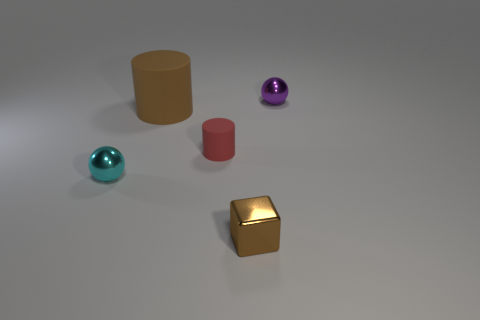How many metal things are either spheres or tiny cyan balls?
Make the answer very short. 2. Do the big brown cylinder and the cyan sphere have the same material?
Give a very brief answer. No. There is a ball that is behind the metallic sphere in front of the purple ball; what is it made of?
Give a very brief answer. Metal. How many tiny things are either metallic cubes or rubber cylinders?
Provide a short and direct response. 2. The purple shiny object has what size?
Your answer should be very brief. Small. Are there more balls that are in front of the brown rubber object than tiny cyan things?
Ensure brevity in your answer.  No. Are there an equal number of small cyan shiny balls in front of the cyan metal thing and large brown rubber cylinders in front of the small brown thing?
Offer a terse response. Yes. The small shiny thing that is both in front of the tiny purple metallic thing and behind the tiny brown metal block is what color?
Ensure brevity in your answer.  Cyan. Is there any other thing that has the same size as the brown metal cube?
Provide a succinct answer. Yes. Is the number of brown things behind the large brown cylinder greater than the number of tiny cyan metallic objects in front of the tiny brown metal object?
Ensure brevity in your answer.  No. 